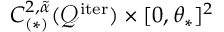<formula> <loc_0><loc_0><loc_500><loc_500>C _ { ( * ) } ^ { 2 , \tilde { \alpha } } ( \mathcal { Q } ^ { i t e r } ) \times [ 0 , \theta _ { * } ] ^ { 2 }</formula> 